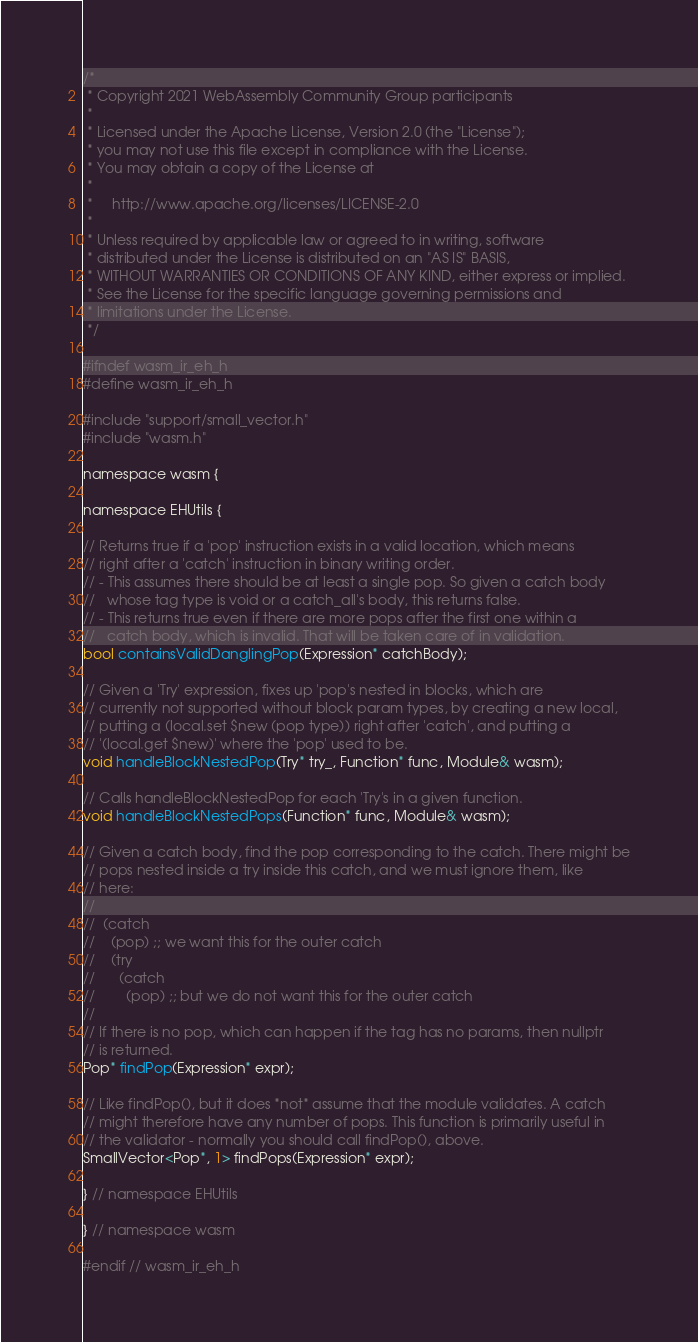<code> <loc_0><loc_0><loc_500><loc_500><_C_>/*
 * Copyright 2021 WebAssembly Community Group participants
 *
 * Licensed under the Apache License, Version 2.0 (the "License");
 * you may not use this file except in compliance with the License.
 * You may obtain a copy of the License at
 *
 *     http://www.apache.org/licenses/LICENSE-2.0
 *
 * Unless required by applicable law or agreed to in writing, software
 * distributed under the License is distributed on an "AS IS" BASIS,
 * WITHOUT WARRANTIES OR CONDITIONS OF ANY KIND, either express or implied.
 * See the License for the specific language governing permissions and
 * limitations under the License.
 */

#ifndef wasm_ir_eh_h
#define wasm_ir_eh_h

#include "support/small_vector.h"
#include "wasm.h"

namespace wasm {

namespace EHUtils {

// Returns true if a 'pop' instruction exists in a valid location, which means
// right after a 'catch' instruction in binary writing order.
// - This assumes there should be at least a single pop. So given a catch body
//   whose tag type is void or a catch_all's body, this returns false.
// - This returns true even if there are more pops after the first one within a
//   catch body, which is invalid. That will be taken care of in validation.
bool containsValidDanglingPop(Expression* catchBody);

// Given a 'Try' expression, fixes up 'pop's nested in blocks, which are
// currently not supported without block param types, by creating a new local,
// putting a (local.set $new (pop type)) right after 'catch', and putting a
// '(local.get $new)' where the 'pop' used to be.
void handleBlockNestedPop(Try* try_, Function* func, Module& wasm);

// Calls handleBlockNestedPop for each 'Try's in a given function.
void handleBlockNestedPops(Function* func, Module& wasm);

// Given a catch body, find the pop corresponding to the catch. There might be
// pops nested inside a try inside this catch, and we must ignore them, like
// here:
//
//  (catch
//    (pop) ;; we want this for the outer catch
//    (try
//      (catch
//        (pop) ;; but we do not want this for the outer catch
//
// If there is no pop, which can happen if the tag has no params, then nullptr
// is returned.
Pop* findPop(Expression* expr);

// Like findPop(), but it does *not* assume that the module validates. A catch
// might therefore have any number of pops. This function is primarily useful in
// the validator - normally you should call findPop(), above.
SmallVector<Pop*, 1> findPops(Expression* expr);

} // namespace EHUtils

} // namespace wasm

#endif // wasm_ir_eh_h
</code> 